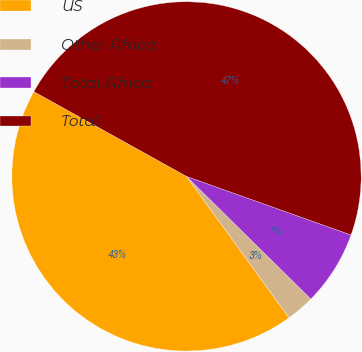Convert chart. <chart><loc_0><loc_0><loc_500><loc_500><pie_chart><fcel>US<fcel>Other Africa<fcel>Total Africa<fcel>Total<nl><fcel>43.05%<fcel>2.62%<fcel>6.95%<fcel>47.38%<nl></chart> 